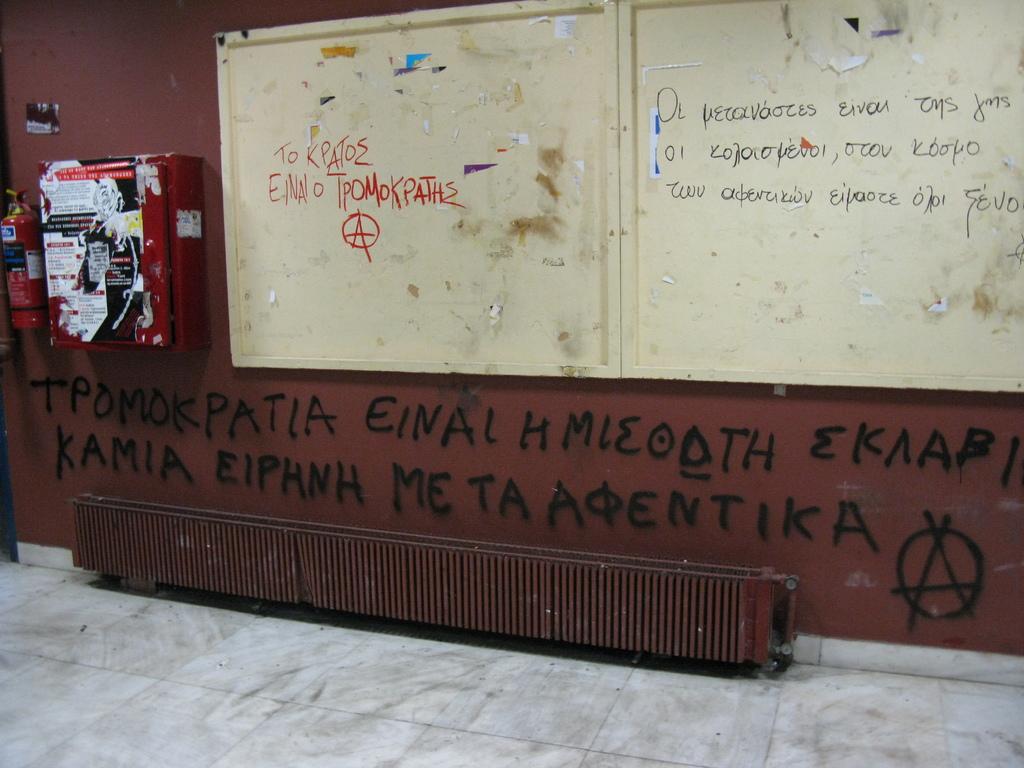What is written on the wall in red paint?
Your response must be concise. Unanswerable. 